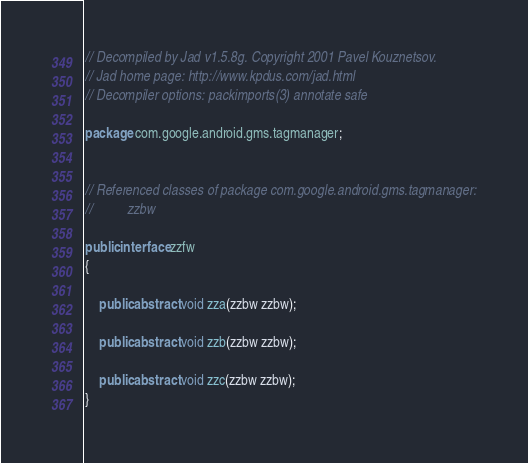Convert code to text. <code><loc_0><loc_0><loc_500><loc_500><_Java_>// Decompiled by Jad v1.5.8g. Copyright 2001 Pavel Kouznetsov.
// Jad home page: http://www.kpdus.com/jad.html
// Decompiler options: packimports(3) annotate safe 

package com.google.android.gms.tagmanager;


// Referenced classes of package com.google.android.gms.tagmanager:
//			zzbw

public interface zzfw
{

	public abstract void zza(zzbw zzbw);

	public abstract void zzb(zzbw zzbw);

	public abstract void zzc(zzbw zzbw);
}
</code> 